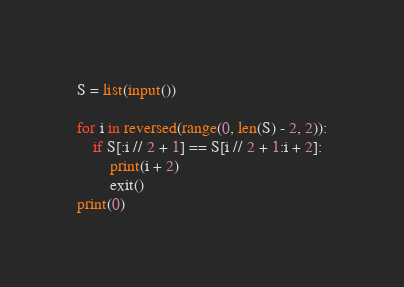Convert code to text. <code><loc_0><loc_0><loc_500><loc_500><_Python_>S = list(input())

for i in reversed(range(0, len(S) - 2, 2)):
    if S[:i // 2 + 1] == S[i // 2 + 1:i + 2]:
        print(i + 2)
        exit()
print(0)</code> 